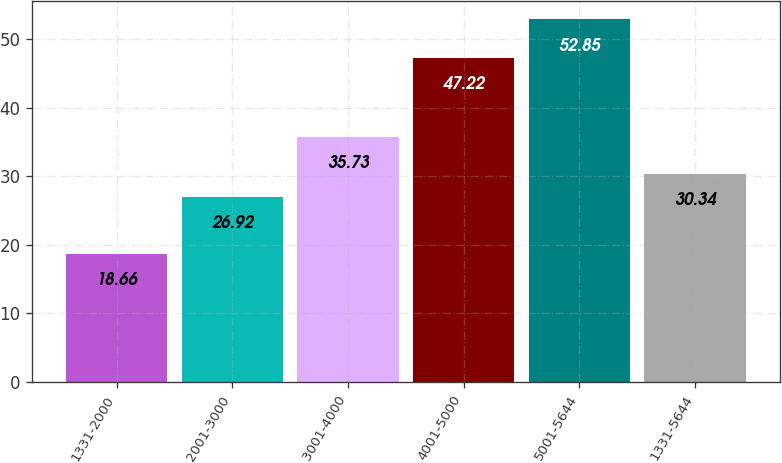<chart> <loc_0><loc_0><loc_500><loc_500><bar_chart><fcel>1331-2000<fcel>2001-3000<fcel>3001-4000<fcel>4001-5000<fcel>5001-5644<fcel>1331-5644<nl><fcel>18.66<fcel>26.92<fcel>35.73<fcel>47.22<fcel>52.85<fcel>30.34<nl></chart> 